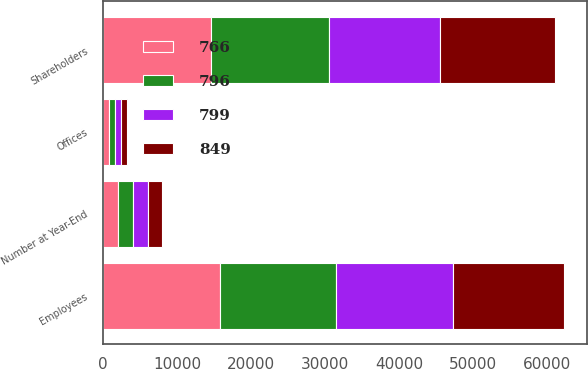Convert chart to OTSL. <chart><loc_0><loc_0><loc_500><loc_500><stacked_bar_chart><ecel><fcel>Number at Year-End<fcel>Shareholders<fcel>Employees<fcel>Offices<nl><fcel>766<fcel>2014<fcel>14551<fcel>15782<fcel>766<nl><fcel>799<fcel>2013<fcel>15015<fcel>15893<fcel>796<nl><fcel>849<fcel>2012<fcel>15623<fcel>14943<fcel>799<nl><fcel>796<fcel>2011<fcel>15959<fcel>15666<fcel>849<nl></chart> 